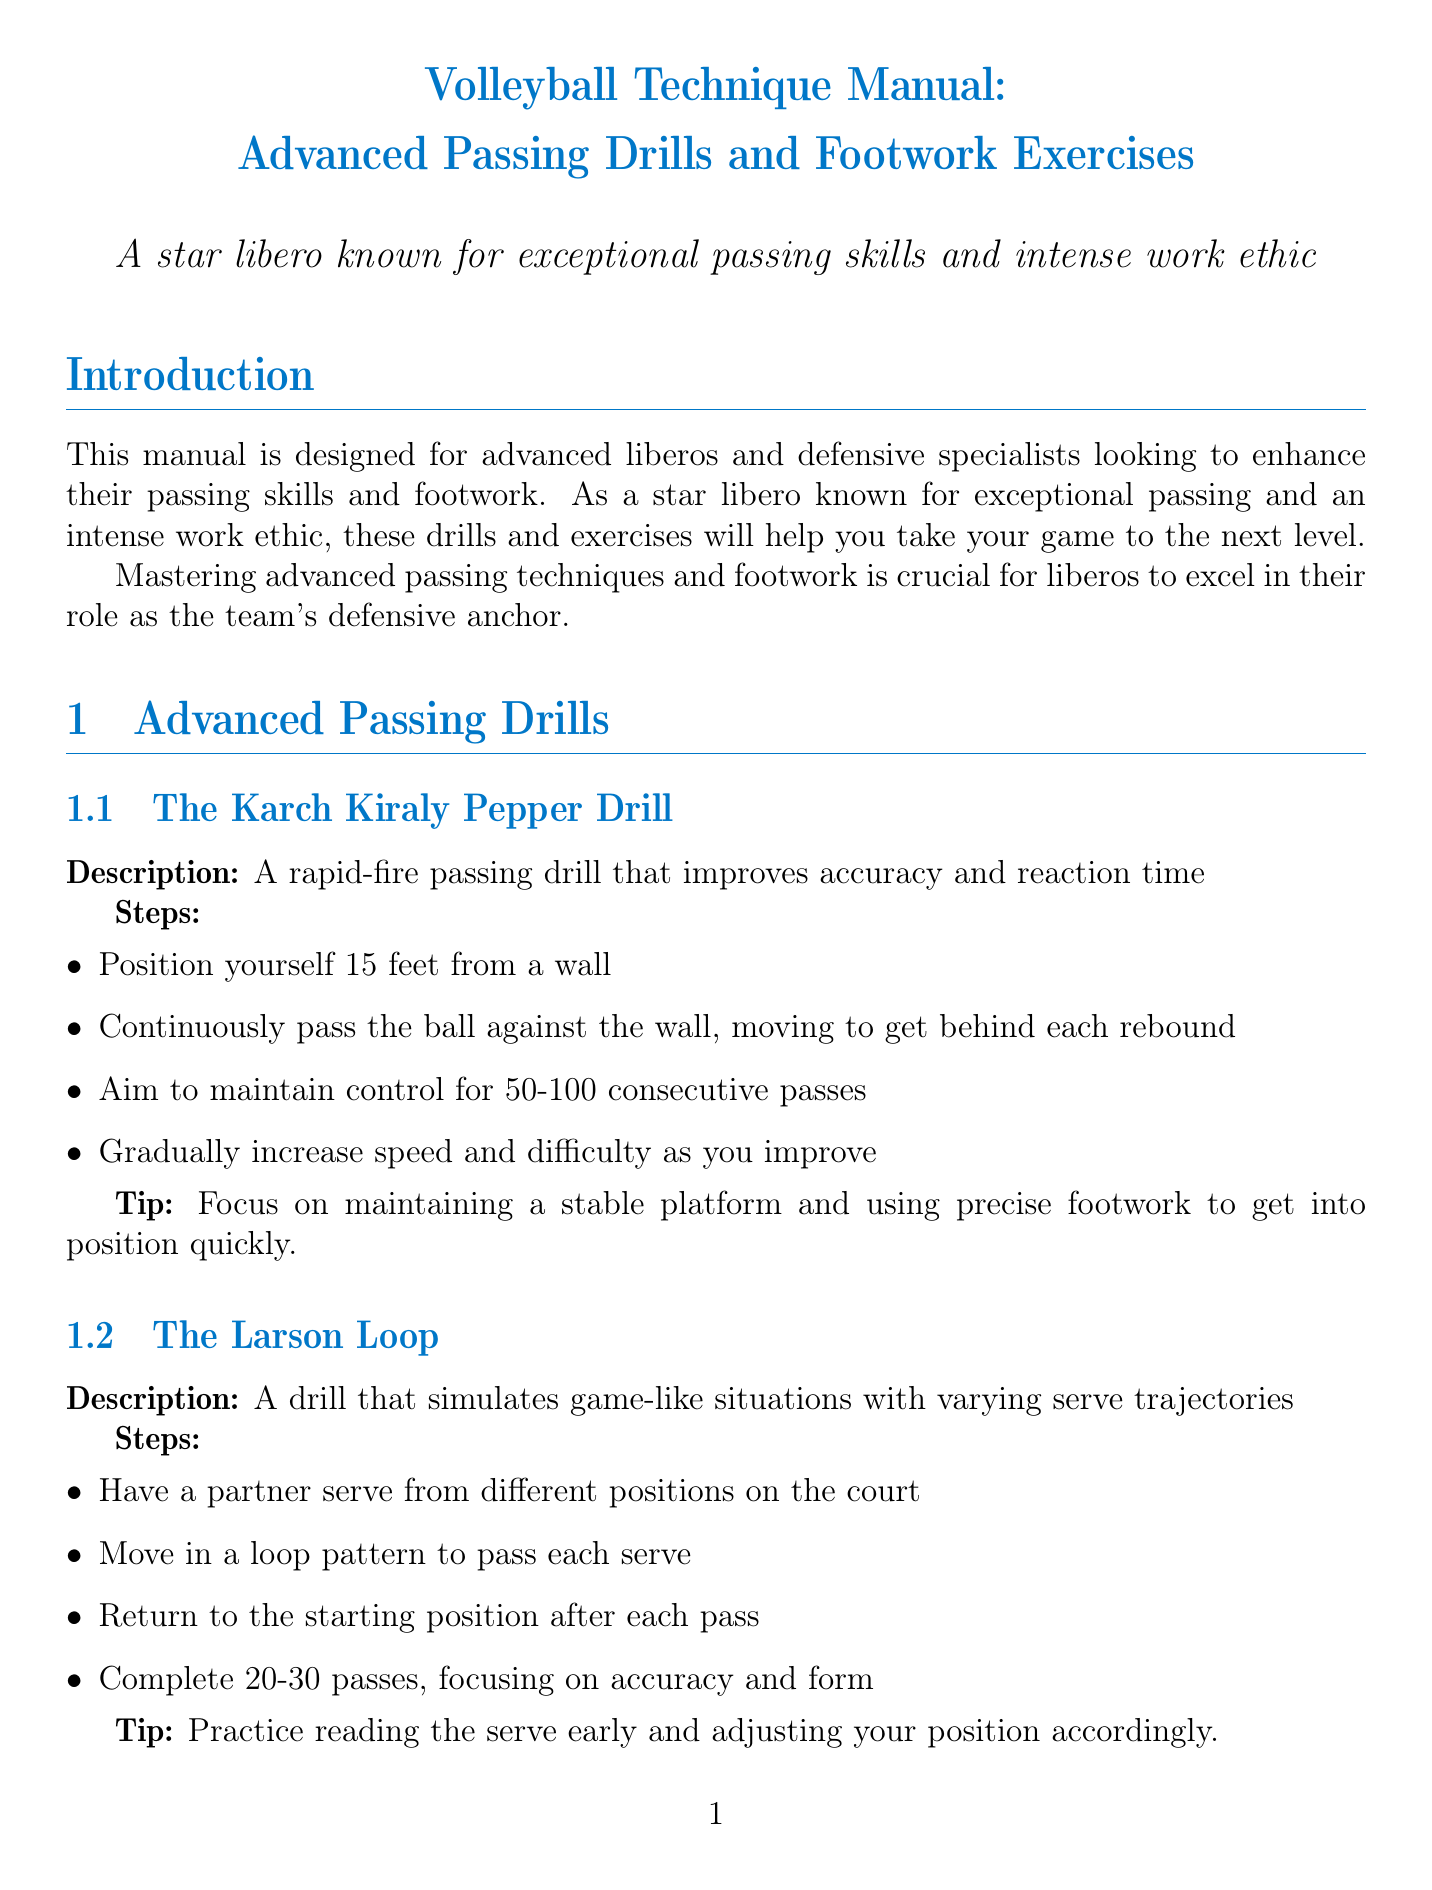what is the title of the manual? The title is mentioned at the beginning of the document.
Answer: Volleyball Technique Manual: Advanced Passing Drills and Footwork Exercises how many advanced passing drills are described? The number of drills is specified in the section on advanced passing drills.
Answer: 3 what is the first drill listed under advanced passing drills? The first drill is indicated in the list found in the advanced passing drills section.
Answer: The Karch Kiraly Pepper Drill what is the purpose of "The Mônica Rodrigues React and Pass Drill"? The purpose can be inferred from the description of the drill.
Answer: Combining quick reactions, footwork, and passing accuracy how long should the Brenda Schultz Shuffle exercise be performed? The duration is specified in the steps for the Brenda Schultz Shuffle exercise.
Answer: 30 seconds what is a key tip for "The Erik Shoji Precision Passing Challenge"? Tips are listed under each drill; this one focuses on accuracy.
Answer: Concentrate on the angle of your platform and the contact point with the ball how many steps are there in the Jenia Grebennikov Cross-Step Drill? The steps are explicitly outlined in the drill description.
Answer: 5 what type of exercises does the section after Advanced Passing Drills focus on? The section title indicates the type of exercises that follow the passing drills.
Answer: Footwork Exercises what is emphasized in the conclusion of the manual? The conclusion summarizes the manual's overall focus and intent.
Answer: Enhance your skills as a libero 